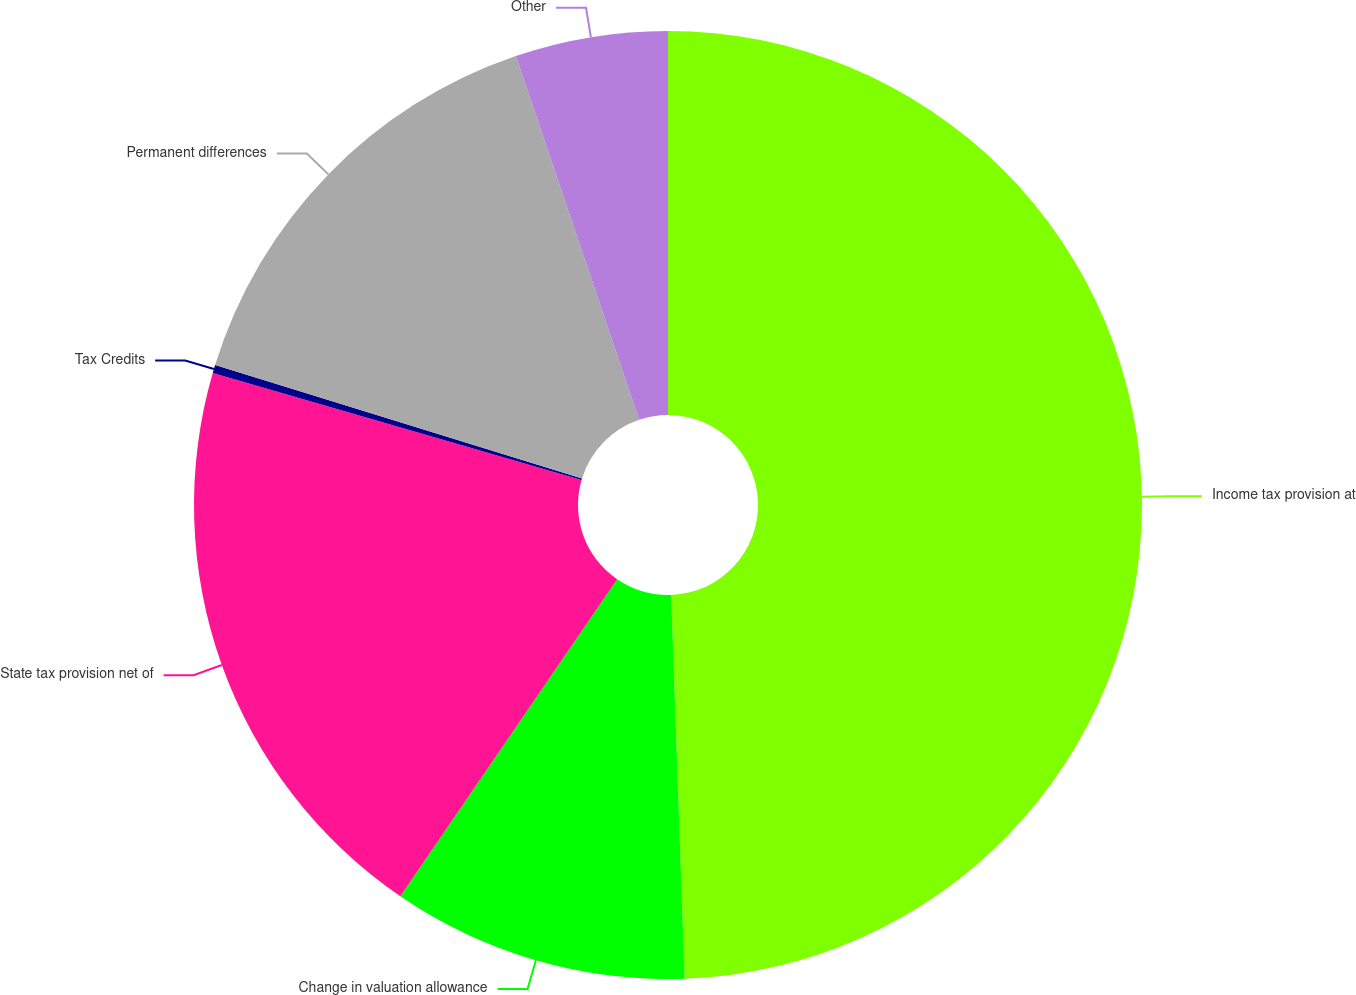<chart> <loc_0><loc_0><loc_500><loc_500><pie_chart><fcel>Income tax provision at<fcel>Change in valuation allowance<fcel>State tax provision net of<fcel>Tax Credits<fcel>Permanent differences<fcel>Other<nl><fcel>49.44%<fcel>10.11%<fcel>19.94%<fcel>0.28%<fcel>15.03%<fcel>5.2%<nl></chart> 